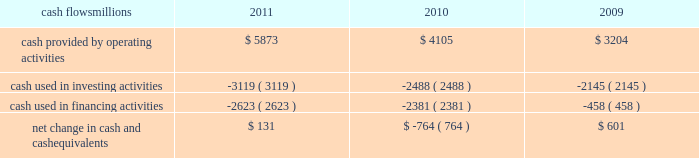Liquidity and capital resources as of december 31 , 2011 , our principal sources of liquidity included cash , cash equivalents , our receivables securitization facility , and our revolving credit facility , as well as the availability of commercial paper and other sources of financing through the capital markets .
We had $ 1.8 billion of committed credit available under our credit facility , with no borrowings outstanding as of december 31 , 2011 .
We did not make any borrowings under this facility during 2011 .
The value of the outstanding undivided interest held by investors under the receivables securitization facility was $ 100 million as of december 31 , 2011 , and is included in our consolidated statements of financial position as debt due after one year .
The receivables securitization facility obligates us to maintain an investment grade bond rating .
If our bond rating were to deteriorate , it could have an adverse impact on our liquidity .
Access to commercial paper as well as other capital market financings is dependent on market conditions .
Deterioration of our operating results or financial condition due to internal or external factors could negatively impact our ability to access capital markets as a source of liquidity .
Access to liquidity through the capital markets is also dependent on our financial stability .
We expect that we will continue to have access to liquidity by issuing bonds to public or private investors based on our assessment of the current condition of the credit markets .
At december 31 , 2011 and 2010 , we had a working capital surplus .
This reflects a strong cash position , which provides enhanced liquidity in an uncertain economic environment .
In addition , we believe we have adequate access to capital markets to meet cash requirements , and we have sufficient financial capacity to satisfy our current liabilities .
Cash flows millions 2011 2010 2009 .
Operating activities higher net income and lower cash income tax payments in 2011 increased cash provided by operating activities compared to 2010 .
The tax relief , unemployment insurance reauthorization , and job creation act of 2010 , enacted in december 2010 , provided for 100% ( 100 % ) bonus depreciation for qualified investments made during 2011 , and 50% ( 50 % ) bonus depreciation for qualified investments made during 2012 .
As a result of the act , the company deferred a substantial portion of its 2011 income tax expense .
This deferral decreased 2011 income tax payments , thereby contributing to the positive operating cash flow .
In future years , however , additional cash will be used to pay income taxes that were previously deferred .
In addition , the adoption of a new accounting standard in january of 2010 changed the accounting treatment for our receivables securitization facility from a sale of undivided interests ( recorded as an operating activity ) to a secured borrowing ( recorded as a financing activity ) , which decreased cash provided by operating activities by $ 400 million in 2010 .
Higher net income in 2010 increased cash provided by operating activities compared to 2009 .
Investing activities higher capital investments partially offset by higher proceeds from asset sales in 2011 drove the increase in cash used in investing activities compared to 2010 .
Higher capital investments and lower proceeds from asset sales in 2010 drove the increase in cash used in investing activities compared to 2009. .
What was the percentage increase in bonus deprecation rates for 2012 capital additions? 
Computations: (100% - 50%)
Answer: 0.5. 